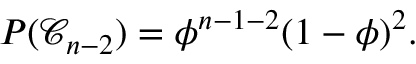Convert formula to latex. <formula><loc_0><loc_0><loc_500><loc_500>P ( \mathcal { C } _ { n - 2 } ) = \phi ^ { n - 1 - 2 } ( 1 - \phi ) ^ { 2 } .</formula> 